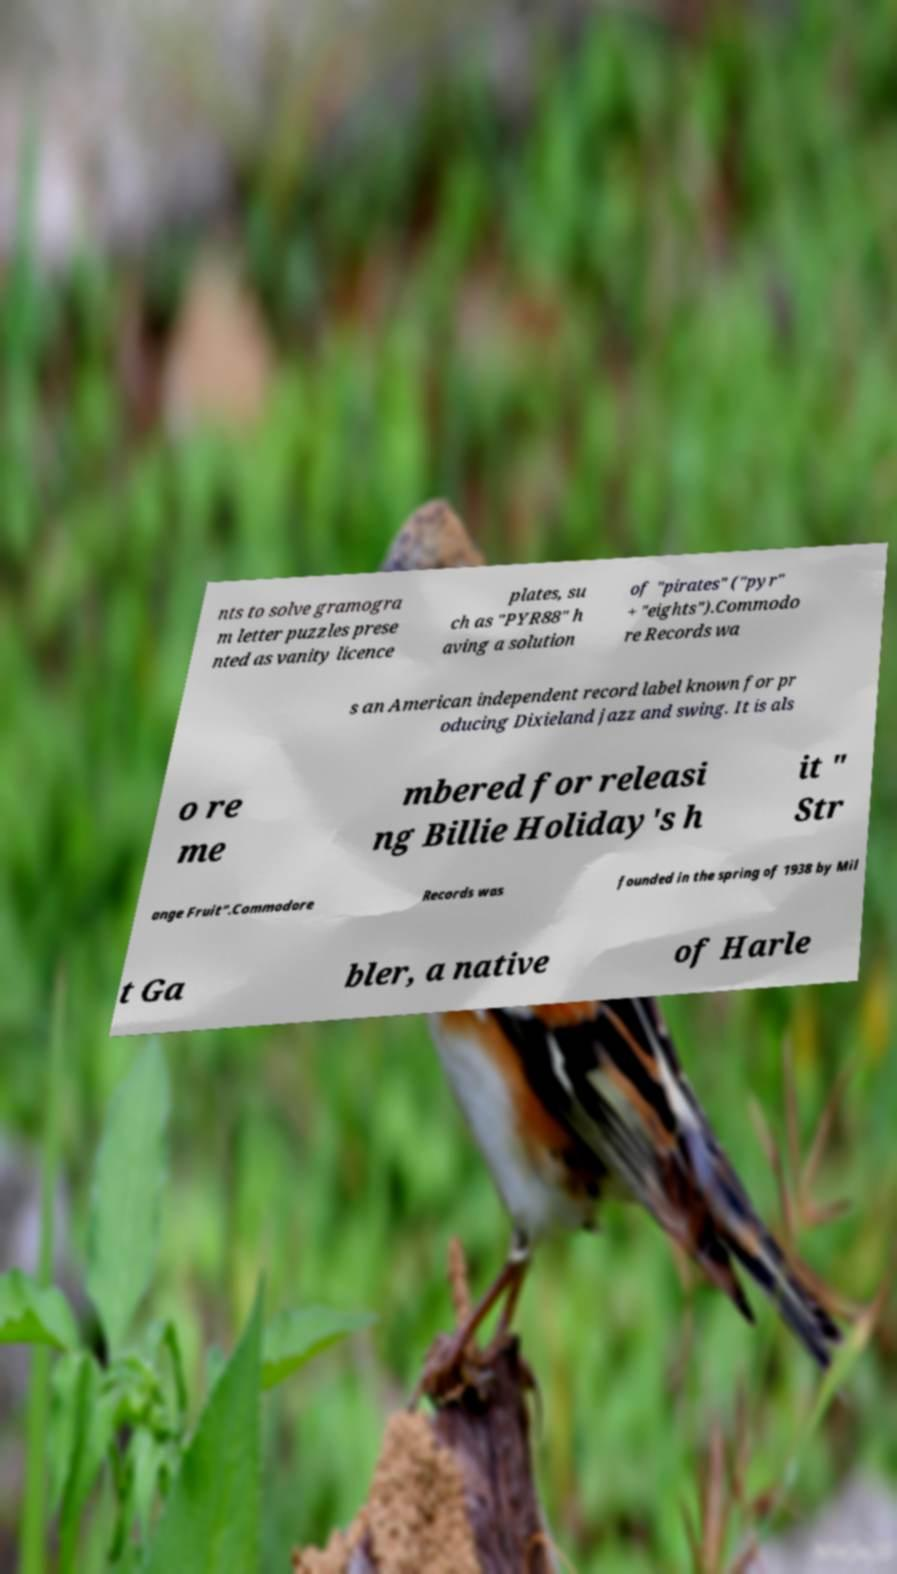Could you extract and type out the text from this image? nts to solve gramogra m letter puzzles prese nted as vanity licence plates, su ch as "PYR88" h aving a solution of "pirates" ("pyr" + "eights").Commodo re Records wa s an American independent record label known for pr oducing Dixieland jazz and swing. It is als o re me mbered for releasi ng Billie Holiday's h it " Str ange Fruit".Commodore Records was founded in the spring of 1938 by Mil t Ga bler, a native of Harle 